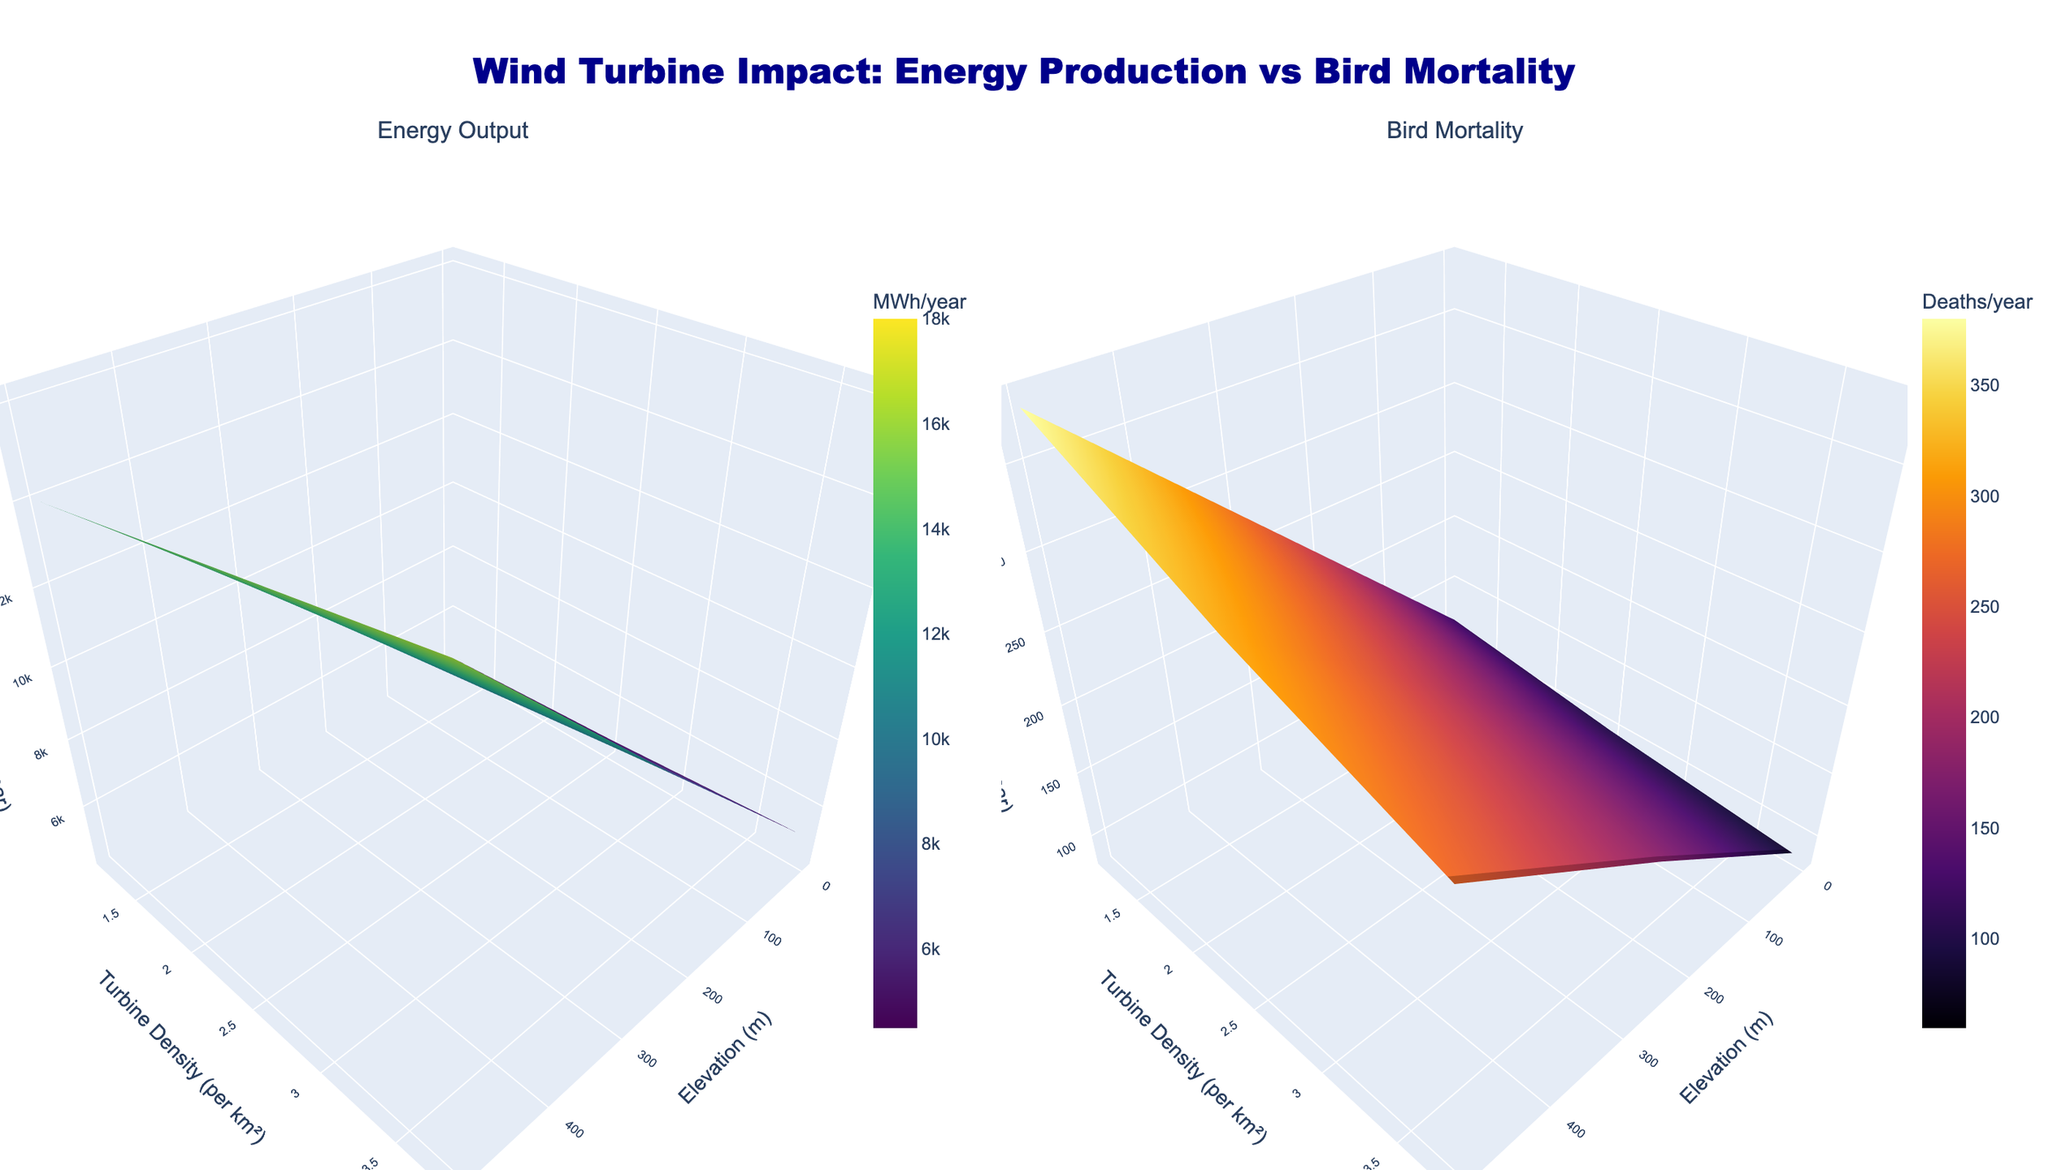What is the title of the entire figure? The title is displayed at the top center of the figure. It reads "Wind Turbine Impact: Energy Production vs Bird Mortality".
Answer: Wind Turbine Impact: Energy Production vs Bird Mortality What are the units for the z-axis in the "Energy Output" subplot? In the "Energy Output" subplot, the z-axis is labeled, and the unit is mentioned as "MWh/year".
Answer: MWh/year Which subplot uses the "Inferno" color scale? The "Inferno" color scale is used in the subplot that displays Bird Mortality. This can be inferred from the color gradient and the associated colorbar.
Answer: Bird Mortality At an elevation of 500 meters and a turbine density of 2.5 per km², what is the approximate bird mortality rate? Locate the point where the elevation is 500 meters and turbine density is 2.5 per km² in the Bird Mortality subplot. The z-value at this point indicates the bird mortality rate, which is around 180 deaths/year.
Answer: 180 deaths/year How does the energy output vary with increasing elevation for a turbine density of 1.2 per km²? In the Energy Output subplot, trace the values on the z-axis at a turbine density of 1.2 per km² while moving along increasing elevation values on the x-axis. The energy output increases from 4500 MWh/year at 0 meters to 6000 MWh/year at 1000 meters.
Answer: It increases At which elevation is the bird mortality lowest regardless of turbine density, and what is the mortality rate? By examining the lowest z-values in the Bird Mortality subplot for various turbine densities, it can be observed that the lowest bird mortality occurs at an elevation of 1000 meters, with a mortality rate of 60 deaths/year.
Answer: 1000 meters, 60 deaths/year For a given elevation, how does bird mortality change with increasing turbine density? In the Bird Mortality subplot, for any fixed elevation, observe how the z-value changes as the y-value (turbine density) increases. Bird mortality increases with higher turbine density.
Answer: It increases Which combination of elevation and turbine density yields the highest energy output? Examine the highest point on the z-axis in the Energy Output subplot. The combination that yields the highest energy output is an elevation of 1000 meters and a turbine density of 3.8 per km², with an output of 18000 MWh/year.
Answer: 1000 meters, 3.8 per km² Is there a trade-off between energy output and bird mortality at any elevation, and what does it imply? By comparing both subplots, observe that high energy output correlates with high bird mortality. For example, at 500 meters elevation and 3.8 turbines/km², high energy output (16000 MWh/year) results in higher bird mortality (270 deaths/year). This implies a trade-off where maximizing energy output increases bird mortality.
Answer: Yes, high energy output correlates with high bird mortality What elevation and turbine density combination should be recommended to minimize bird mortality without significantly compromising energy output? Observing both subplots, find a balance where bird mortality is low, but energy output remains reasonable. At 1000 meters and 1.2 turbines/km², bird mortality is only 60 deaths/year with a decent energy output of 6000 MWh/year.
Answer: 1000 meters, 1.2 turbines/km² 